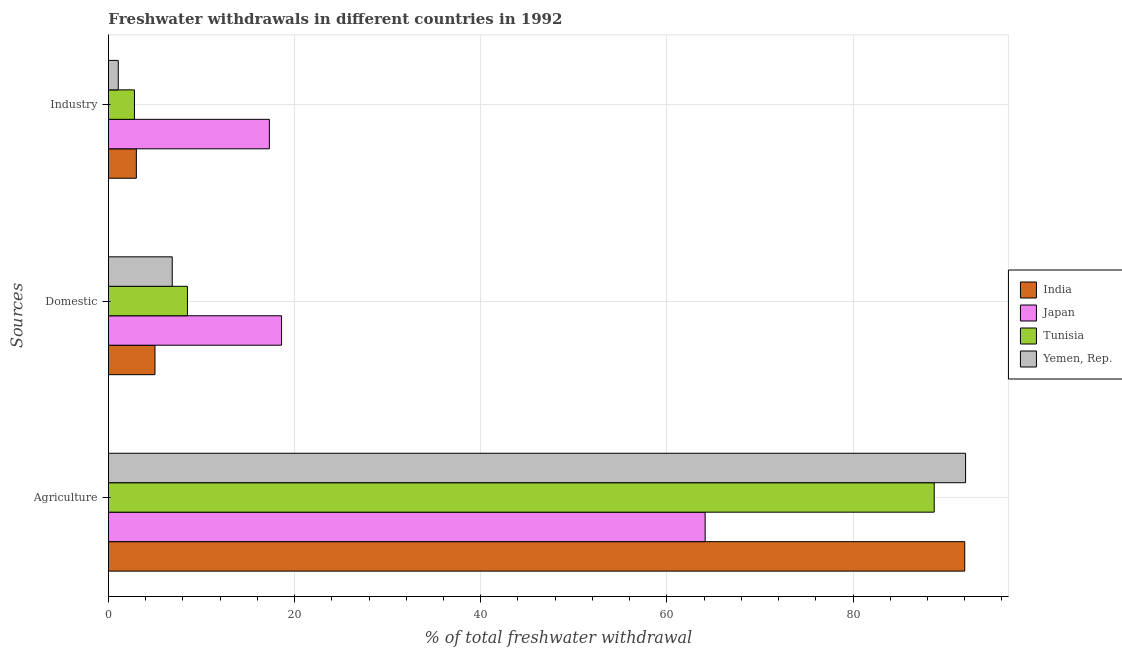How many groups of bars are there?
Provide a succinct answer. 3. Are the number of bars on each tick of the Y-axis equal?
Keep it short and to the point. Yes. What is the label of the 3rd group of bars from the top?
Your response must be concise. Agriculture. What is the percentage of freshwater withdrawal for domestic purposes in India?
Your answer should be compact. 5. In which country was the percentage of freshwater withdrawal for agriculture maximum?
Ensure brevity in your answer.  Yemen, Rep. In which country was the percentage of freshwater withdrawal for agriculture minimum?
Make the answer very short. Japan. What is the total percentage of freshwater withdrawal for industry in the graph?
Keep it short and to the point. 24.14. What is the difference between the percentage of freshwater withdrawal for domestic purposes in India and that in Japan?
Make the answer very short. -13.6. What is the difference between the percentage of freshwater withdrawal for domestic purposes in Japan and the percentage of freshwater withdrawal for agriculture in Yemen, Rep.?
Provide a short and direct response. -73.49. What is the average percentage of freshwater withdrawal for agriculture per country?
Your response must be concise. 84.23. What is the difference between the percentage of freshwater withdrawal for industry and percentage of freshwater withdrawal for domestic purposes in Tunisia?
Your answer should be compact. -5.69. What is the ratio of the percentage of freshwater withdrawal for agriculture in Tunisia to that in India?
Make the answer very short. 0.96. Is the percentage of freshwater withdrawal for industry in Japan less than that in Yemen, Rep.?
Offer a very short reply. No. What is the difference between the highest and the second highest percentage of freshwater withdrawal for industry?
Keep it short and to the point. 14.29. What is the difference between the highest and the lowest percentage of freshwater withdrawal for industry?
Your answer should be very brief. 16.23. In how many countries, is the percentage of freshwater withdrawal for agriculture greater than the average percentage of freshwater withdrawal for agriculture taken over all countries?
Ensure brevity in your answer.  3. Is the sum of the percentage of freshwater withdrawal for agriculture in India and Yemen, Rep. greater than the maximum percentage of freshwater withdrawal for industry across all countries?
Your answer should be compact. Yes. What does the 1st bar from the top in Industry represents?
Make the answer very short. Yemen, Rep. What does the 4th bar from the bottom in Industry represents?
Make the answer very short. Yemen, Rep. Is it the case that in every country, the sum of the percentage of freshwater withdrawal for agriculture and percentage of freshwater withdrawal for domestic purposes is greater than the percentage of freshwater withdrawal for industry?
Your response must be concise. Yes. What is the title of the graph?
Make the answer very short. Freshwater withdrawals in different countries in 1992. What is the label or title of the X-axis?
Make the answer very short. % of total freshwater withdrawal. What is the label or title of the Y-axis?
Keep it short and to the point. Sources. What is the % of total freshwater withdrawal of India in Agriculture?
Keep it short and to the point. 92. What is the % of total freshwater withdrawal of Japan in Agriculture?
Offer a very short reply. 64.11. What is the % of total freshwater withdrawal in Tunisia in Agriculture?
Give a very brief answer. 88.72. What is the % of total freshwater withdrawal of Yemen, Rep. in Agriculture?
Your answer should be very brief. 92.09. What is the % of total freshwater withdrawal in Japan in Domestic?
Provide a short and direct response. 18.6. What is the % of total freshwater withdrawal in Tunisia in Domestic?
Provide a succinct answer. 8.49. What is the % of total freshwater withdrawal of Yemen, Rep. in Domestic?
Your answer should be compact. 6.86. What is the % of total freshwater withdrawal of India in Industry?
Give a very brief answer. 3. What is the % of total freshwater withdrawal of Japan in Industry?
Offer a terse response. 17.29. What is the % of total freshwater withdrawal in Tunisia in Industry?
Your response must be concise. 2.8. What is the % of total freshwater withdrawal of Yemen, Rep. in Industry?
Offer a very short reply. 1.06. Across all Sources, what is the maximum % of total freshwater withdrawal in India?
Your response must be concise. 92. Across all Sources, what is the maximum % of total freshwater withdrawal of Japan?
Your response must be concise. 64.11. Across all Sources, what is the maximum % of total freshwater withdrawal of Tunisia?
Make the answer very short. 88.72. Across all Sources, what is the maximum % of total freshwater withdrawal of Yemen, Rep.?
Your answer should be very brief. 92.09. Across all Sources, what is the minimum % of total freshwater withdrawal in India?
Your answer should be very brief. 3. Across all Sources, what is the minimum % of total freshwater withdrawal of Japan?
Your answer should be very brief. 17.29. Across all Sources, what is the minimum % of total freshwater withdrawal in Tunisia?
Give a very brief answer. 2.8. Across all Sources, what is the minimum % of total freshwater withdrawal in Yemen, Rep.?
Offer a very short reply. 1.06. What is the total % of total freshwater withdrawal in India in the graph?
Offer a very short reply. 100. What is the total % of total freshwater withdrawal of Tunisia in the graph?
Give a very brief answer. 100. What is the total % of total freshwater withdrawal of Yemen, Rep. in the graph?
Ensure brevity in your answer.  100. What is the difference between the % of total freshwater withdrawal of India in Agriculture and that in Domestic?
Your response must be concise. 87. What is the difference between the % of total freshwater withdrawal of Japan in Agriculture and that in Domestic?
Provide a short and direct response. 45.51. What is the difference between the % of total freshwater withdrawal in Tunisia in Agriculture and that in Domestic?
Offer a very short reply. 80.23. What is the difference between the % of total freshwater withdrawal of Yemen, Rep. in Agriculture and that in Domestic?
Keep it short and to the point. 85.23. What is the difference between the % of total freshwater withdrawal of India in Agriculture and that in Industry?
Ensure brevity in your answer.  89. What is the difference between the % of total freshwater withdrawal in Japan in Agriculture and that in Industry?
Ensure brevity in your answer.  46.82. What is the difference between the % of total freshwater withdrawal in Tunisia in Agriculture and that in Industry?
Provide a short and direct response. 85.92. What is the difference between the % of total freshwater withdrawal in Yemen, Rep. in Agriculture and that in Industry?
Keep it short and to the point. 91.03. What is the difference between the % of total freshwater withdrawal of India in Domestic and that in Industry?
Offer a very short reply. 2. What is the difference between the % of total freshwater withdrawal of Japan in Domestic and that in Industry?
Give a very brief answer. 1.31. What is the difference between the % of total freshwater withdrawal of Tunisia in Domestic and that in Industry?
Give a very brief answer. 5.69. What is the difference between the % of total freshwater withdrawal of Yemen, Rep. in Domestic and that in Industry?
Give a very brief answer. 5.8. What is the difference between the % of total freshwater withdrawal in India in Agriculture and the % of total freshwater withdrawal in Japan in Domestic?
Ensure brevity in your answer.  73.4. What is the difference between the % of total freshwater withdrawal of India in Agriculture and the % of total freshwater withdrawal of Tunisia in Domestic?
Offer a very short reply. 83.51. What is the difference between the % of total freshwater withdrawal in India in Agriculture and the % of total freshwater withdrawal in Yemen, Rep. in Domestic?
Your answer should be compact. 85.14. What is the difference between the % of total freshwater withdrawal in Japan in Agriculture and the % of total freshwater withdrawal in Tunisia in Domestic?
Offer a very short reply. 55.62. What is the difference between the % of total freshwater withdrawal of Japan in Agriculture and the % of total freshwater withdrawal of Yemen, Rep. in Domestic?
Offer a very short reply. 57.26. What is the difference between the % of total freshwater withdrawal in Tunisia in Agriculture and the % of total freshwater withdrawal in Yemen, Rep. in Domestic?
Offer a terse response. 81.86. What is the difference between the % of total freshwater withdrawal in India in Agriculture and the % of total freshwater withdrawal in Japan in Industry?
Your response must be concise. 74.71. What is the difference between the % of total freshwater withdrawal of India in Agriculture and the % of total freshwater withdrawal of Tunisia in Industry?
Provide a short and direct response. 89.2. What is the difference between the % of total freshwater withdrawal in India in Agriculture and the % of total freshwater withdrawal in Yemen, Rep. in Industry?
Your answer should be compact. 90.94. What is the difference between the % of total freshwater withdrawal in Japan in Agriculture and the % of total freshwater withdrawal in Tunisia in Industry?
Keep it short and to the point. 61.31. What is the difference between the % of total freshwater withdrawal of Japan in Agriculture and the % of total freshwater withdrawal of Yemen, Rep. in Industry?
Your answer should be very brief. 63.05. What is the difference between the % of total freshwater withdrawal in Tunisia in Agriculture and the % of total freshwater withdrawal in Yemen, Rep. in Industry?
Keep it short and to the point. 87.66. What is the difference between the % of total freshwater withdrawal of India in Domestic and the % of total freshwater withdrawal of Japan in Industry?
Ensure brevity in your answer.  -12.29. What is the difference between the % of total freshwater withdrawal in India in Domestic and the % of total freshwater withdrawal in Tunisia in Industry?
Provide a short and direct response. 2.2. What is the difference between the % of total freshwater withdrawal of India in Domestic and the % of total freshwater withdrawal of Yemen, Rep. in Industry?
Keep it short and to the point. 3.94. What is the difference between the % of total freshwater withdrawal in Japan in Domestic and the % of total freshwater withdrawal in Tunisia in Industry?
Your answer should be very brief. 15.8. What is the difference between the % of total freshwater withdrawal in Japan in Domestic and the % of total freshwater withdrawal in Yemen, Rep. in Industry?
Your answer should be very brief. 17.54. What is the difference between the % of total freshwater withdrawal in Tunisia in Domestic and the % of total freshwater withdrawal in Yemen, Rep. in Industry?
Make the answer very short. 7.43. What is the average % of total freshwater withdrawal in India per Sources?
Ensure brevity in your answer.  33.33. What is the average % of total freshwater withdrawal of Japan per Sources?
Ensure brevity in your answer.  33.33. What is the average % of total freshwater withdrawal of Tunisia per Sources?
Ensure brevity in your answer.  33.34. What is the average % of total freshwater withdrawal of Yemen, Rep. per Sources?
Ensure brevity in your answer.  33.33. What is the difference between the % of total freshwater withdrawal of India and % of total freshwater withdrawal of Japan in Agriculture?
Provide a short and direct response. 27.89. What is the difference between the % of total freshwater withdrawal of India and % of total freshwater withdrawal of Tunisia in Agriculture?
Make the answer very short. 3.28. What is the difference between the % of total freshwater withdrawal in India and % of total freshwater withdrawal in Yemen, Rep. in Agriculture?
Make the answer very short. -0.09. What is the difference between the % of total freshwater withdrawal of Japan and % of total freshwater withdrawal of Tunisia in Agriculture?
Offer a very short reply. -24.61. What is the difference between the % of total freshwater withdrawal in Japan and % of total freshwater withdrawal in Yemen, Rep. in Agriculture?
Give a very brief answer. -27.98. What is the difference between the % of total freshwater withdrawal in Tunisia and % of total freshwater withdrawal in Yemen, Rep. in Agriculture?
Your answer should be compact. -3.37. What is the difference between the % of total freshwater withdrawal in India and % of total freshwater withdrawal in Japan in Domestic?
Your answer should be very brief. -13.6. What is the difference between the % of total freshwater withdrawal in India and % of total freshwater withdrawal in Tunisia in Domestic?
Make the answer very short. -3.49. What is the difference between the % of total freshwater withdrawal in India and % of total freshwater withdrawal in Yemen, Rep. in Domestic?
Provide a succinct answer. -1.85. What is the difference between the % of total freshwater withdrawal of Japan and % of total freshwater withdrawal of Tunisia in Domestic?
Make the answer very short. 10.11. What is the difference between the % of total freshwater withdrawal in Japan and % of total freshwater withdrawal in Yemen, Rep. in Domestic?
Your answer should be compact. 11.74. What is the difference between the % of total freshwater withdrawal in Tunisia and % of total freshwater withdrawal in Yemen, Rep. in Domestic?
Keep it short and to the point. 1.63. What is the difference between the % of total freshwater withdrawal of India and % of total freshwater withdrawal of Japan in Industry?
Ensure brevity in your answer.  -14.29. What is the difference between the % of total freshwater withdrawal of India and % of total freshwater withdrawal of Tunisia in Industry?
Provide a short and direct response. 0.2. What is the difference between the % of total freshwater withdrawal in India and % of total freshwater withdrawal in Yemen, Rep. in Industry?
Your answer should be very brief. 1.94. What is the difference between the % of total freshwater withdrawal of Japan and % of total freshwater withdrawal of Tunisia in Industry?
Make the answer very short. 14.49. What is the difference between the % of total freshwater withdrawal in Japan and % of total freshwater withdrawal in Yemen, Rep. in Industry?
Ensure brevity in your answer.  16.23. What is the difference between the % of total freshwater withdrawal of Tunisia and % of total freshwater withdrawal of Yemen, Rep. in Industry?
Your response must be concise. 1.74. What is the ratio of the % of total freshwater withdrawal in Japan in Agriculture to that in Domestic?
Your answer should be compact. 3.45. What is the ratio of the % of total freshwater withdrawal of Tunisia in Agriculture to that in Domestic?
Your answer should be very brief. 10.45. What is the ratio of the % of total freshwater withdrawal in Yemen, Rep. in Agriculture to that in Domestic?
Keep it short and to the point. 13.43. What is the ratio of the % of total freshwater withdrawal in India in Agriculture to that in Industry?
Your answer should be compact. 30.67. What is the ratio of the % of total freshwater withdrawal of Japan in Agriculture to that in Industry?
Keep it short and to the point. 3.71. What is the ratio of the % of total freshwater withdrawal of Tunisia in Agriculture to that in Industry?
Keep it short and to the point. 31.72. What is the ratio of the % of total freshwater withdrawal in Yemen, Rep. in Agriculture to that in Industry?
Make the answer very short. 87.12. What is the ratio of the % of total freshwater withdrawal in Japan in Domestic to that in Industry?
Ensure brevity in your answer.  1.08. What is the ratio of the % of total freshwater withdrawal of Tunisia in Domestic to that in Industry?
Ensure brevity in your answer.  3.03. What is the ratio of the % of total freshwater withdrawal in Yemen, Rep. in Domestic to that in Industry?
Provide a short and direct response. 6.49. What is the difference between the highest and the second highest % of total freshwater withdrawal of India?
Give a very brief answer. 87. What is the difference between the highest and the second highest % of total freshwater withdrawal in Japan?
Offer a very short reply. 45.51. What is the difference between the highest and the second highest % of total freshwater withdrawal in Tunisia?
Offer a terse response. 80.23. What is the difference between the highest and the second highest % of total freshwater withdrawal in Yemen, Rep.?
Provide a succinct answer. 85.23. What is the difference between the highest and the lowest % of total freshwater withdrawal in India?
Your answer should be very brief. 89. What is the difference between the highest and the lowest % of total freshwater withdrawal in Japan?
Give a very brief answer. 46.82. What is the difference between the highest and the lowest % of total freshwater withdrawal of Tunisia?
Give a very brief answer. 85.92. What is the difference between the highest and the lowest % of total freshwater withdrawal of Yemen, Rep.?
Provide a succinct answer. 91.03. 